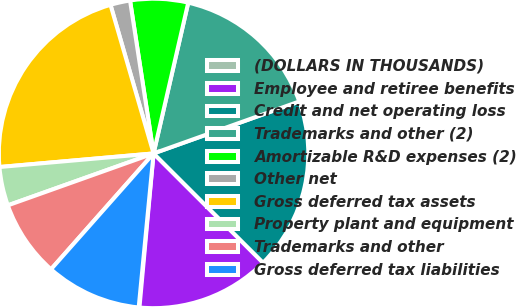<chart> <loc_0><loc_0><loc_500><loc_500><pie_chart><fcel>(DOLLARS IN THOUSANDS)<fcel>Employee and retiree benefits<fcel>Credit and net operating loss<fcel>Trademarks and other (2)<fcel>Amortizable R&D expenses (2)<fcel>Other net<fcel>Gross deferred tax assets<fcel>Property plant and equipment<fcel>Trademarks and other<fcel>Gross deferred tax liabilities<nl><fcel>0.08%<fcel>13.97%<fcel>17.94%<fcel>15.95%<fcel>6.03%<fcel>2.06%<fcel>21.91%<fcel>4.05%<fcel>8.02%<fcel>10.0%<nl></chart> 